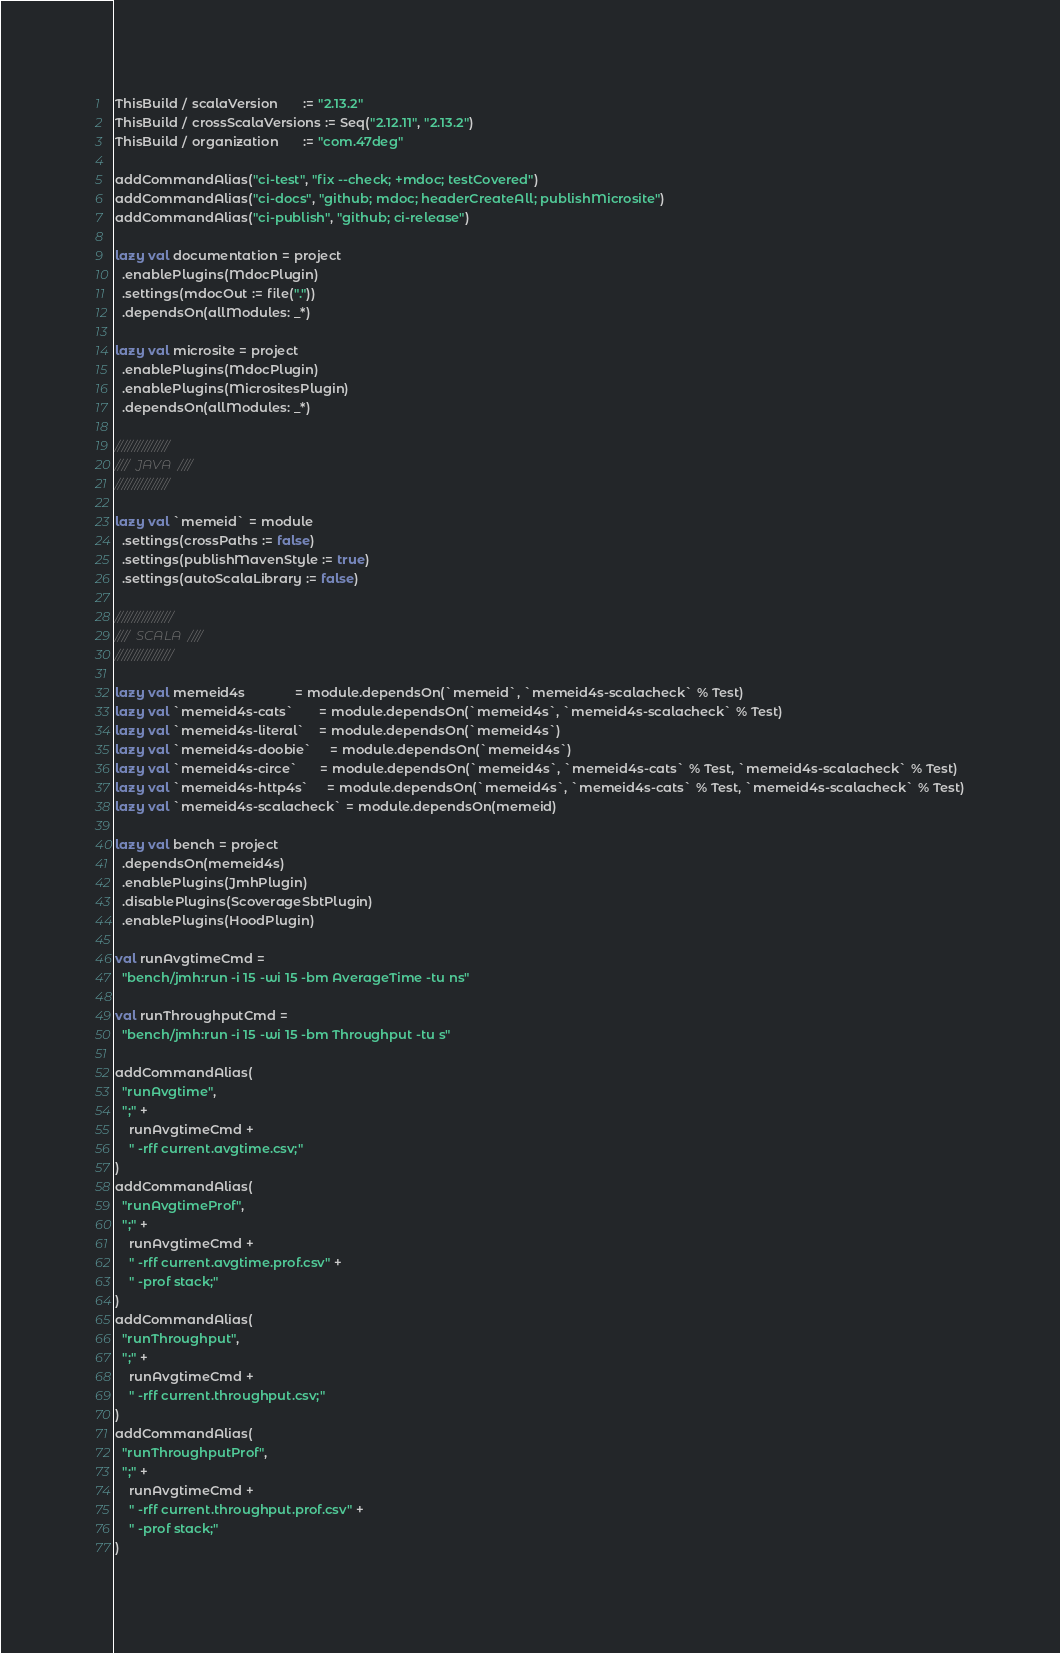Convert code to text. <code><loc_0><loc_0><loc_500><loc_500><_Scala_>ThisBuild / scalaVersion       := "2.13.2"
ThisBuild / crossScalaVersions := Seq("2.12.11", "2.13.2")
ThisBuild / organization       := "com.47deg"

addCommandAlias("ci-test", "fix --check; +mdoc; testCovered")
addCommandAlias("ci-docs", "github; mdoc; headerCreateAll; publishMicrosite")
addCommandAlias("ci-publish", "github; ci-release")

lazy val documentation = project
  .enablePlugins(MdocPlugin)
  .settings(mdocOut := file("."))
  .dependsOn(allModules: _*)

lazy val microsite = project
  .enablePlugins(MdocPlugin)
  .enablePlugins(MicrositesPlugin)
  .dependsOn(allModules: _*)

////////////////
////  JAVA  ////
////////////////

lazy val `memeid` = module
  .settings(crossPaths := false)
  .settings(publishMavenStyle := true)
  .settings(autoScalaLibrary := false)

/////////////////
////  SCALA  ////
/////////////////

lazy val memeid4s              = module.dependsOn(`memeid`, `memeid4s-scalacheck` % Test)
lazy val `memeid4s-cats`       = module.dependsOn(`memeid4s`, `memeid4s-scalacheck` % Test)
lazy val `memeid4s-literal`    = module.dependsOn(`memeid4s`)
lazy val `memeid4s-doobie`     = module.dependsOn(`memeid4s`)
lazy val `memeid4s-circe`      = module.dependsOn(`memeid4s`, `memeid4s-cats` % Test, `memeid4s-scalacheck` % Test)
lazy val `memeid4s-http4s`     = module.dependsOn(`memeid4s`, `memeid4s-cats` % Test, `memeid4s-scalacheck` % Test)
lazy val `memeid4s-scalacheck` = module.dependsOn(memeid)

lazy val bench = project
  .dependsOn(memeid4s)
  .enablePlugins(JmhPlugin)
  .disablePlugins(ScoverageSbtPlugin)
  .enablePlugins(HoodPlugin)

val runAvgtimeCmd =
  "bench/jmh:run -i 15 -wi 15 -bm AverageTime -tu ns"

val runThroughputCmd =
  "bench/jmh:run -i 15 -wi 15 -bm Throughput -tu s"

addCommandAlias(
  "runAvgtime",
  ";" +
    runAvgtimeCmd +
    " -rff current.avgtime.csv;"
)
addCommandAlias(
  "runAvgtimeProf",
  ";" +
    runAvgtimeCmd +
    " -rff current.avgtime.prof.csv" +
    " -prof stack;"
)
addCommandAlias(
  "runThroughput",
  ";" +
    runAvgtimeCmd +
    " -rff current.throughput.csv;"
)
addCommandAlias(
  "runThroughputProf",
  ";" +
    runAvgtimeCmd +
    " -rff current.throughput.prof.csv" +
    " -prof stack;"
)
</code> 